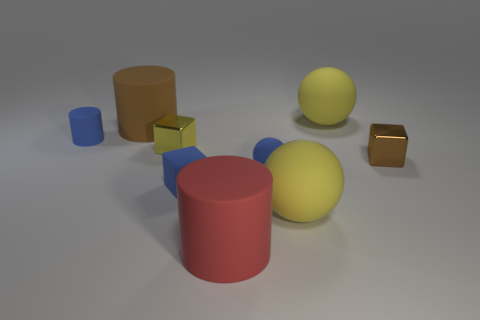There is a blue sphere that is the same size as the brown metallic thing; what is its material?
Offer a terse response. Rubber. How many large objects are either red matte objects or yellow things?
Your answer should be compact. 3. Are there any red matte cylinders?
Make the answer very short. Yes. There is a blue sphere that is the same material as the big red object; what is its size?
Ensure brevity in your answer.  Small. Is the material of the tiny cylinder the same as the tiny blue sphere?
Offer a very short reply. Yes. How many other things are made of the same material as the tiny yellow object?
Offer a terse response. 1. How many blue rubber things are behind the brown metallic object and in front of the small matte cylinder?
Provide a succinct answer. 0. The small sphere has what color?
Keep it short and to the point. Blue. What material is the small yellow thing that is the same shape as the tiny brown shiny thing?
Your answer should be very brief. Metal. Is there any other thing that is made of the same material as the small blue ball?
Keep it short and to the point. Yes. 